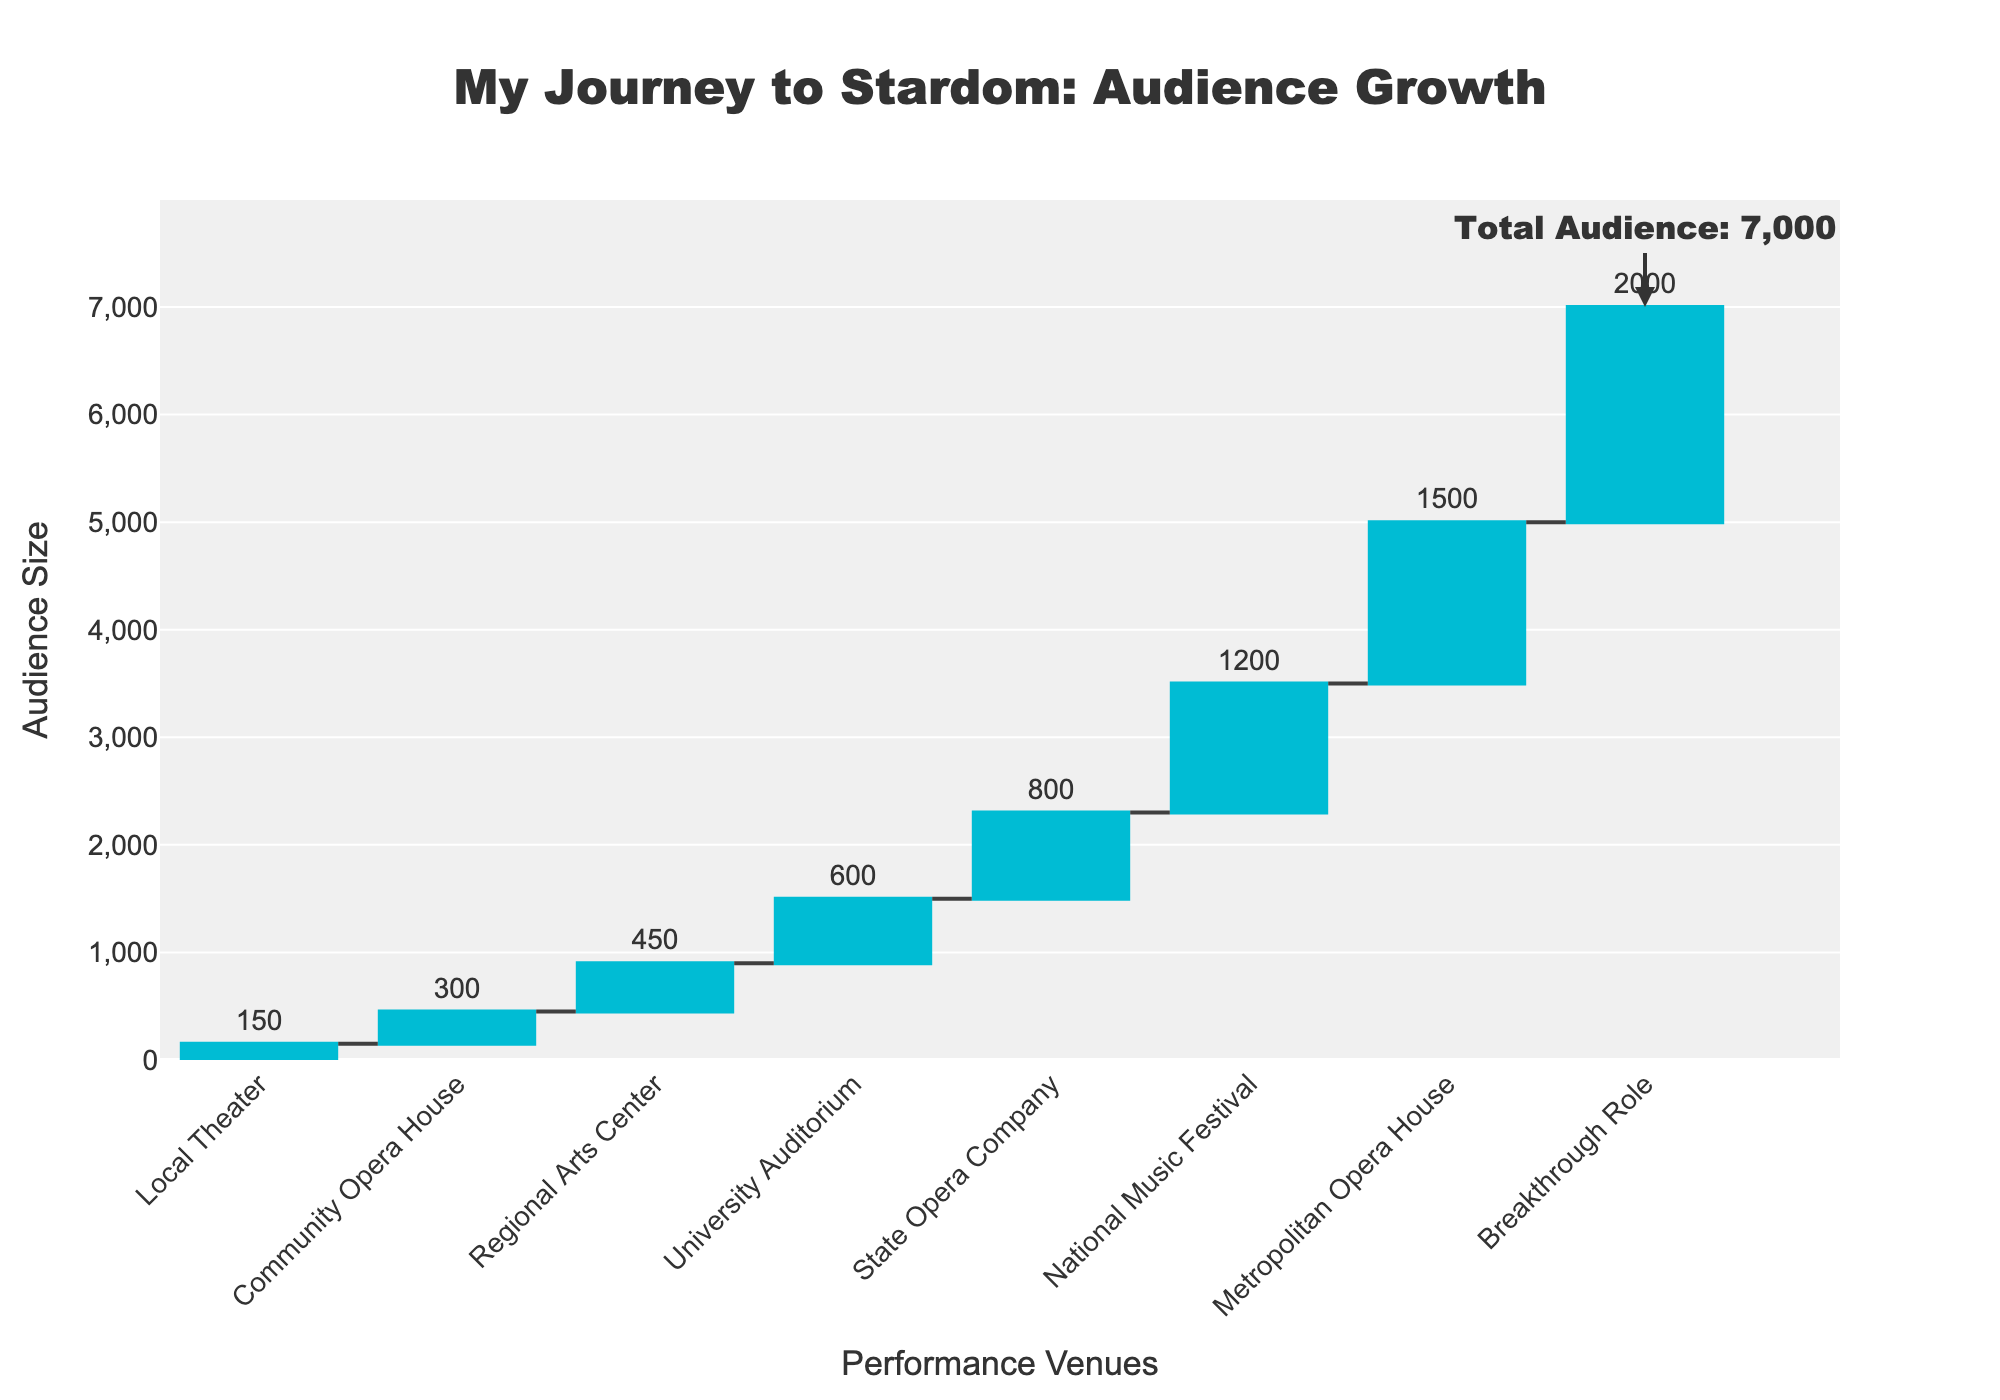What's the title of the figure? The title is displayed at the top of the plot and provides an overview of what the plot represents. In this case, it reads "My Journey to Stardom: Audience Growth."
Answer: My Journey to Stardom: Audience Growth How many performance venues are shown before the breakthrough role? The x-axis of the waterfall chart lists all performance venues along with the breakthrough role. Counting the venues listed before 'Breakthrough Role' gives the total number.
Answer: 7 Which performance venue experienced the largest audience increase? To find the largest audience increase, look at the height of the bars. The highest bar corresponds to the National Music Festival, showing an increase of 1200.
Answer: National Music Festival What was the audience size at the Metropolitan Opera House? According to the figure, the bar labeled "Metropolitan Opera House" shows an audience size of 1500.
Answer: 1500 What is the total audience size by the time of the breakthrough role? The annotation at the end of the "Breakthrough Role" bar indicates the cumulative audience size, which is 5,800.
Answer: 5,800 How much did the audience grow from the University Auditorium to the State Opera Company? The audience at the University Auditorium was 600, and it increased to 800 at the State Opera Company. Subtract 600 from 800 to find the growth.
Answer: 200 What is the average audience size across all venues before the breakthrough role? Sum the audience sizes for all venues before the breakthrough role (150 + 300 + 450 + 600 + 800 + 1200 + 1500) for a total of 5,000. There are 7 venues, so divide 5,000 by 7.
Answer: ~714 Which venue had a smaller audience size, Local Theater or Community Opera House? By comparing the bars for "Local Theater" (150) and "Community Opera House" (300), it's clear that the Local Theater had a smaller audience size.
Answer: Local Theater Between which two venues did the audience double? Look for pairs of consecutive bars where the second is roughly twice the first. The audience grows from 600 at University Auditorium to 800 at State Opera Company (not a double), but it goes from 300 at Community Opera House to 450 at Regional Arts Center, which is a 1.5x increase, so it didn't double. Instead, it doubles from 800 to 1500, so from State Opera Company to Metropolitan Opera House.
Answer: State Opera Company to Metropolitan Opera House 